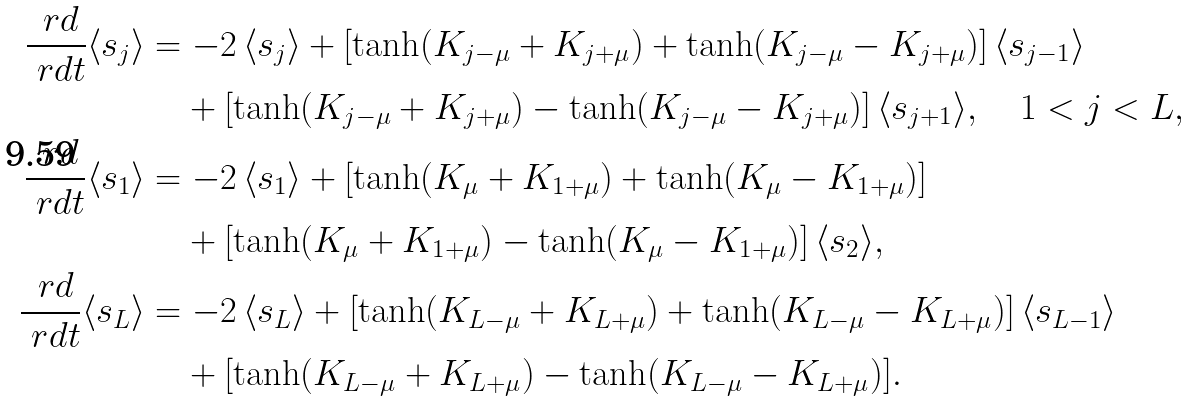Convert formula to latex. <formula><loc_0><loc_0><loc_500><loc_500>\frac { \ r d } { \ r d t } \langle s _ { j } \rangle & = - 2 \, \langle s _ { j } \rangle + [ \tanh ( K _ { j - \mu } + K _ { j + \mu } ) + \tanh ( K _ { j - \mu } - K _ { j + \mu } ) ] \, \langle s _ { j - 1 } \rangle \\ & \quad + [ \tanh ( K _ { j - \mu } + K _ { j + \mu } ) - \tanh ( K _ { j - \mu } - K _ { j + \mu } ) ] \, \langle s _ { j + 1 } \rangle , \quad 1 < j < L , \\ \frac { \ r d } { \ r d t } \langle s _ { 1 } \rangle & = - 2 \, \langle s _ { 1 } \rangle + [ \tanh ( K _ { \mu } + K _ { 1 + \mu } ) + \tanh ( K _ { \mu } - K _ { 1 + \mu } ) ] \\ & \quad + [ \tanh ( K _ { \mu } + K _ { 1 + \mu } ) - \tanh ( K _ { \mu } - K _ { 1 + \mu } ) ] \, \langle s _ { 2 } \rangle , \\ \frac { \ r d } { \ r d t } \langle s _ { L } \rangle & = - 2 \, \langle s _ { L } \rangle + [ \tanh ( K _ { L - \mu } + K _ { L + \mu } ) + \tanh ( K _ { L - \mu } - K _ { L + \mu } ) ] \, \langle s _ { L - 1 } \rangle \\ & \quad + [ \tanh ( K _ { L - \mu } + K _ { L + \mu } ) - \tanh ( K _ { L - \mu } - K _ { L + \mu } ) ] .</formula> 